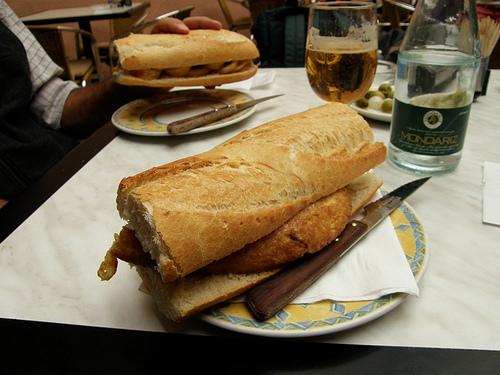What are the toothpicks doing?
Keep it brief. Nothing. What beverages are on the table?
Concise answer only. Beer and water. Where are the olives?
Write a very short answer. On plate. Do you see a steak knife or butter knife?
Give a very brief answer. Steak. What is the object in front of the sandwiches?
Concise answer only. Knife. What color is the plate?
Be succinct. Yellow. 